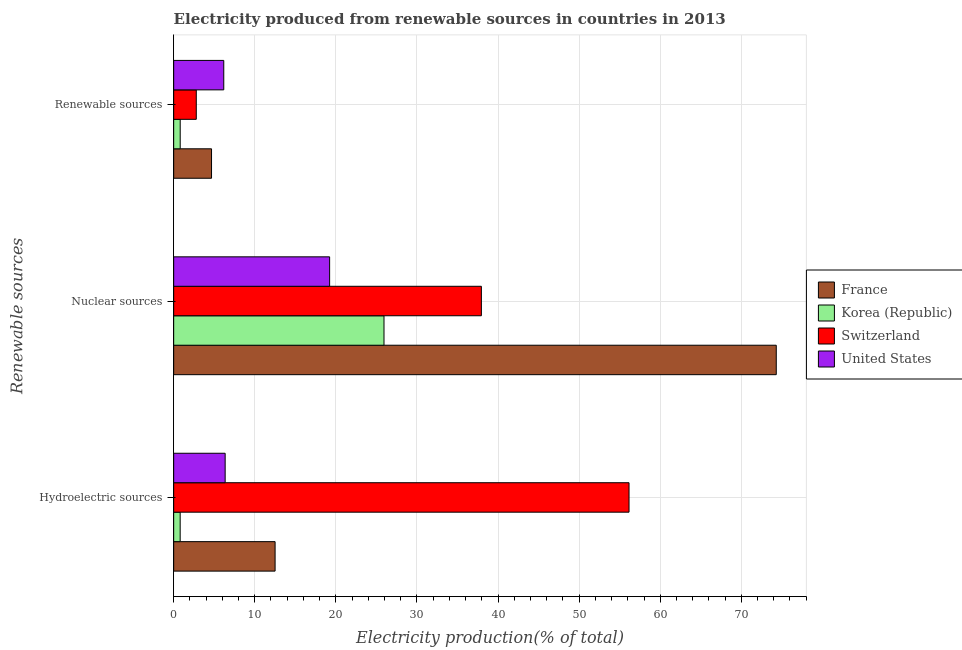How many different coloured bars are there?
Your response must be concise. 4. Are the number of bars on each tick of the Y-axis equal?
Offer a terse response. Yes. How many bars are there on the 3rd tick from the top?
Your answer should be very brief. 4. What is the label of the 2nd group of bars from the top?
Your answer should be very brief. Nuclear sources. What is the percentage of electricity produced by renewable sources in United States?
Provide a short and direct response. 6.18. Across all countries, what is the maximum percentage of electricity produced by renewable sources?
Keep it short and to the point. 6.18. Across all countries, what is the minimum percentage of electricity produced by renewable sources?
Provide a short and direct response. 0.81. What is the total percentage of electricity produced by hydroelectric sources in the graph?
Make the answer very short. 75.81. What is the difference between the percentage of electricity produced by nuclear sources in Switzerland and that in Korea (Republic)?
Your response must be concise. 12.01. What is the difference between the percentage of electricity produced by hydroelectric sources in United States and the percentage of electricity produced by renewable sources in Switzerland?
Ensure brevity in your answer.  3.56. What is the average percentage of electricity produced by renewable sources per country?
Your response must be concise. 3.61. What is the difference between the percentage of electricity produced by renewable sources and percentage of electricity produced by hydroelectric sources in United States?
Make the answer very short. -0.17. What is the ratio of the percentage of electricity produced by nuclear sources in Switzerland to that in Korea (Republic)?
Your response must be concise. 1.46. Is the difference between the percentage of electricity produced by renewable sources in France and Switzerland greater than the difference between the percentage of electricity produced by nuclear sources in France and Switzerland?
Your answer should be very brief. No. What is the difference between the highest and the second highest percentage of electricity produced by nuclear sources?
Make the answer very short. 36.36. What is the difference between the highest and the lowest percentage of electricity produced by nuclear sources?
Offer a very short reply. 55.08. What does the 1st bar from the top in Nuclear sources represents?
Offer a very short reply. United States. What does the 1st bar from the bottom in Hydroelectric sources represents?
Make the answer very short. France. Are all the bars in the graph horizontal?
Ensure brevity in your answer.  Yes. How many countries are there in the graph?
Offer a terse response. 4. What is the difference between two consecutive major ticks on the X-axis?
Your answer should be compact. 10. Are the values on the major ticks of X-axis written in scientific E-notation?
Give a very brief answer. No. How are the legend labels stacked?
Your answer should be very brief. Vertical. What is the title of the graph?
Your response must be concise. Electricity produced from renewable sources in countries in 2013. What is the label or title of the X-axis?
Ensure brevity in your answer.  Electricity production(% of total). What is the label or title of the Y-axis?
Ensure brevity in your answer.  Renewable sources. What is the Electricity production(% of total) of France in Hydroelectric sources?
Make the answer very short. 12.51. What is the Electricity production(% of total) in Korea (Republic) in Hydroelectric sources?
Ensure brevity in your answer.  0.8. What is the Electricity production(% of total) in Switzerland in Hydroelectric sources?
Provide a short and direct response. 56.15. What is the Electricity production(% of total) in United States in Hydroelectric sources?
Your response must be concise. 6.35. What is the Electricity production(% of total) of France in Nuclear sources?
Your response must be concise. 74.31. What is the Electricity production(% of total) of Korea (Republic) in Nuclear sources?
Offer a very short reply. 25.94. What is the Electricity production(% of total) in Switzerland in Nuclear sources?
Provide a short and direct response. 37.95. What is the Electricity production(% of total) in United States in Nuclear sources?
Keep it short and to the point. 19.23. What is the Electricity production(% of total) in France in Renewable sources?
Provide a succinct answer. 4.67. What is the Electricity production(% of total) in Korea (Republic) in Renewable sources?
Your answer should be compact. 0.81. What is the Electricity production(% of total) of Switzerland in Renewable sources?
Keep it short and to the point. 2.79. What is the Electricity production(% of total) in United States in Renewable sources?
Your answer should be compact. 6.18. Across all Renewable sources, what is the maximum Electricity production(% of total) of France?
Your answer should be compact. 74.31. Across all Renewable sources, what is the maximum Electricity production(% of total) of Korea (Republic)?
Provide a succinct answer. 25.94. Across all Renewable sources, what is the maximum Electricity production(% of total) in Switzerland?
Offer a terse response. 56.15. Across all Renewable sources, what is the maximum Electricity production(% of total) of United States?
Provide a succinct answer. 19.23. Across all Renewable sources, what is the minimum Electricity production(% of total) in France?
Offer a very short reply. 4.67. Across all Renewable sources, what is the minimum Electricity production(% of total) in Korea (Republic)?
Make the answer very short. 0.8. Across all Renewable sources, what is the minimum Electricity production(% of total) in Switzerland?
Give a very brief answer. 2.79. Across all Renewable sources, what is the minimum Electricity production(% of total) in United States?
Give a very brief answer. 6.18. What is the total Electricity production(% of total) of France in the graph?
Keep it short and to the point. 91.49. What is the total Electricity production(% of total) of Korea (Republic) in the graph?
Provide a short and direct response. 27.54. What is the total Electricity production(% of total) in Switzerland in the graph?
Your response must be concise. 96.89. What is the total Electricity production(% of total) in United States in the graph?
Provide a short and direct response. 31.76. What is the difference between the Electricity production(% of total) in France in Hydroelectric sources and that in Nuclear sources?
Make the answer very short. -61.8. What is the difference between the Electricity production(% of total) in Korea (Republic) in Hydroelectric sources and that in Nuclear sources?
Provide a succinct answer. -25.14. What is the difference between the Electricity production(% of total) in Switzerland in Hydroelectric sources and that in Nuclear sources?
Your response must be concise. 18.21. What is the difference between the Electricity production(% of total) in United States in Hydroelectric sources and that in Nuclear sources?
Ensure brevity in your answer.  -12.88. What is the difference between the Electricity production(% of total) of France in Hydroelectric sources and that in Renewable sources?
Ensure brevity in your answer.  7.84. What is the difference between the Electricity production(% of total) in Korea (Republic) in Hydroelectric sources and that in Renewable sources?
Provide a succinct answer. -0. What is the difference between the Electricity production(% of total) of Switzerland in Hydroelectric sources and that in Renewable sources?
Offer a terse response. 53.37. What is the difference between the Electricity production(% of total) in United States in Hydroelectric sources and that in Renewable sources?
Make the answer very short. 0.17. What is the difference between the Electricity production(% of total) of France in Nuclear sources and that in Renewable sources?
Make the answer very short. 69.64. What is the difference between the Electricity production(% of total) of Korea (Republic) in Nuclear sources and that in Renewable sources?
Make the answer very short. 25.13. What is the difference between the Electricity production(% of total) of Switzerland in Nuclear sources and that in Renewable sources?
Make the answer very short. 35.16. What is the difference between the Electricity production(% of total) in United States in Nuclear sources and that in Renewable sources?
Provide a short and direct response. 13.05. What is the difference between the Electricity production(% of total) of France in Hydroelectric sources and the Electricity production(% of total) of Korea (Republic) in Nuclear sources?
Provide a short and direct response. -13.43. What is the difference between the Electricity production(% of total) in France in Hydroelectric sources and the Electricity production(% of total) in Switzerland in Nuclear sources?
Your response must be concise. -25.44. What is the difference between the Electricity production(% of total) in France in Hydroelectric sources and the Electricity production(% of total) in United States in Nuclear sources?
Ensure brevity in your answer.  -6.72. What is the difference between the Electricity production(% of total) of Korea (Republic) in Hydroelectric sources and the Electricity production(% of total) of Switzerland in Nuclear sources?
Make the answer very short. -37.14. What is the difference between the Electricity production(% of total) of Korea (Republic) in Hydroelectric sources and the Electricity production(% of total) of United States in Nuclear sources?
Give a very brief answer. -18.43. What is the difference between the Electricity production(% of total) of Switzerland in Hydroelectric sources and the Electricity production(% of total) of United States in Nuclear sources?
Provide a succinct answer. 36.92. What is the difference between the Electricity production(% of total) in France in Hydroelectric sources and the Electricity production(% of total) in Korea (Republic) in Renewable sources?
Keep it short and to the point. 11.7. What is the difference between the Electricity production(% of total) of France in Hydroelectric sources and the Electricity production(% of total) of Switzerland in Renewable sources?
Your response must be concise. 9.72. What is the difference between the Electricity production(% of total) of France in Hydroelectric sources and the Electricity production(% of total) of United States in Renewable sources?
Provide a succinct answer. 6.33. What is the difference between the Electricity production(% of total) in Korea (Republic) in Hydroelectric sources and the Electricity production(% of total) in Switzerland in Renewable sources?
Provide a succinct answer. -1.99. What is the difference between the Electricity production(% of total) in Korea (Republic) in Hydroelectric sources and the Electricity production(% of total) in United States in Renewable sources?
Make the answer very short. -5.38. What is the difference between the Electricity production(% of total) of Switzerland in Hydroelectric sources and the Electricity production(% of total) of United States in Renewable sources?
Make the answer very short. 49.98. What is the difference between the Electricity production(% of total) in France in Nuclear sources and the Electricity production(% of total) in Korea (Republic) in Renewable sources?
Provide a succinct answer. 73.5. What is the difference between the Electricity production(% of total) in France in Nuclear sources and the Electricity production(% of total) in Switzerland in Renewable sources?
Give a very brief answer. 71.52. What is the difference between the Electricity production(% of total) of France in Nuclear sources and the Electricity production(% of total) of United States in Renewable sources?
Provide a short and direct response. 68.13. What is the difference between the Electricity production(% of total) of Korea (Republic) in Nuclear sources and the Electricity production(% of total) of Switzerland in Renewable sources?
Your answer should be very brief. 23.15. What is the difference between the Electricity production(% of total) in Korea (Republic) in Nuclear sources and the Electricity production(% of total) in United States in Renewable sources?
Make the answer very short. 19.76. What is the difference between the Electricity production(% of total) in Switzerland in Nuclear sources and the Electricity production(% of total) in United States in Renewable sources?
Offer a terse response. 31.77. What is the average Electricity production(% of total) in France per Renewable sources?
Your response must be concise. 30.5. What is the average Electricity production(% of total) of Korea (Republic) per Renewable sources?
Offer a very short reply. 9.18. What is the average Electricity production(% of total) in Switzerland per Renewable sources?
Provide a succinct answer. 32.3. What is the average Electricity production(% of total) in United States per Renewable sources?
Your response must be concise. 10.59. What is the difference between the Electricity production(% of total) of France and Electricity production(% of total) of Korea (Republic) in Hydroelectric sources?
Provide a short and direct response. 11.71. What is the difference between the Electricity production(% of total) in France and Electricity production(% of total) in Switzerland in Hydroelectric sources?
Offer a terse response. -43.65. What is the difference between the Electricity production(% of total) of France and Electricity production(% of total) of United States in Hydroelectric sources?
Ensure brevity in your answer.  6.16. What is the difference between the Electricity production(% of total) in Korea (Republic) and Electricity production(% of total) in Switzerland in Hydroelectric sources?
Provide a short and direct response. -55.35. What is the difference between the Electricity production(% of total) of Korea (Republic) and Electricity production(% of total) of United States in Hydroelectric sources?
Offer a terse response. -5.55. What is the difference between the Electricity production(% of total) in Switzerland and Electricity production(% of total) in United States in Hydroelectric sources?
Keep it short and to the point. 49.8. What is the difference between the Electricity production(% of total) of France and Electricity production(% of total) of Korea (Republic) in Nuclear sources?
Your answer should be very brief. 48.37. What is the difference between the Electricity production(% of total) of France and Electricity production(% of total) of Switzerland in Nuclear sources?
Provide a short and direct response. 36.36. What is the difference between the Electricity production(% of total) of France and Electricity production(% of total) of United States in Nuclear sources?
Your answer should be compact. 55.08. What is the difference between the Electricity production(% of total) of Korea (Republic) and Electricity production(% of total) of Switzerland in Nuclear sources?
Make the answer very short. -12.01. What is the difference between the Electricity production(% of total) of Korea (Republic) and Electricity production(% of total) of United States in Nuclear sources?
Your response must be concise. 6.71. What is the difference between the Electricity production(% of total) in Switzerland and Electricity production(% of total) in United States in Nuclear sources?
Provide a succinct answer. 18.71. What is the difference between the Electricity production(% of total) of France and Electricity production(% of total) of Korea (Republic) in Renewable sources?
Provide a succinct answer. 3.86. What is the difference between the Electricity production(% of total) in France and Electricity production(% of total) in Switzerland in Renewable sources?
Provide a short and direct response. 1.88. What is the difference between the Electricity production(% of total) in France and Electricity production(% of total) in United States in Renewable sources?
Offer a terse response. -1.51. What is the difference between the Electricity production(% of total) of Korea (Republic) and Electricity production(% of total) of Switzerland in Renewable sources?
Your answer should be compact. -1.98. What is the difference between the Electricity production(% of total) in Korea (Republic) and Electricity production(% of total) in United States in Renewable sources?
Provide a short and direct response. -5.37. What is the difference between the Electricity production(% of total) in Switzerland and Electricity production(% of total) in United States in Renewable sources?
Make the answer very short. -3.39. What is the ratio of the Electricity production(% of total) in France in Hydroelectric sources to that in Nuclear sources?
Make the answer very short. 0.17. What is the ratio of the Electricity production(% of total) of Korea (Republic) in Hydroelectric sources to that in Nuclear sources?
Keep it short and to the point. 0.03. What is the ratio of the Electricity production(% of total) of Switzerland in Hydroelectric sources to that in Nuclear sources?
Provide a succinct answer. 1.48. What is the ratio of the Electricity production(% of total) of United States in Hydroelectric sources to that in Nuclear sources?
Offer a very short reply. 0.33. What is the ratio of the Electricity production(% of total) of France in Hydroelectric sources to that in Renewable sources?
Your answer should be very brief. 2.68. What is the ratio of the Electricity production(% of total) in Switzerland in Hydroelectric sources to that in Renewable sources?
Give a very brief answer. 20.15. What is the ratio of the Electricity production(% of total) in United States in Hydroelectric sources to that in Renewable sources?
Your answer should be very brief. 1.03. What is the ratio of the Electricity production(% of total) in France in Nuclear sources to that in Renewable sources?
Offer a very short reply. 15.91. What is the ratio of the Electricity production(% of total) of Korea (Republic) in Nuclear sources to that in Renewable sources?
Provide a succinct answer. 32.19. What is the ratio of the Electricity production(% of total) of Switzerland in Nuclear sources to that in Renewable sources?
Your response must be concise. 13.61. What is the ratio of the Electricity production(% of total) in United States in Nuclear sources to that in Renewable sources?
Provide a short and direct response. 3.11. What is the difference between the highest and the second highest Electricity production(% of total) of France?
Your answer should be compact. 61.8. What is the difference between the highest and the second highest Electricity production(% of total) of Korea (Republic)?
Provide a succinct answer. 25.13. What is the difference between the highest and the second highest Electricity production(% of total) in Switzerland?
Keep it short and to the point. 18.21. What is the difference between the highest and the second highest Electricity production(% of total) of United States?
Make the answer very short. 12.88. What is the difference between the highest and the lowest Electricity production(% of total) in France?
Your answer should be compact. 69.64. What is the difference between the highest and the lowest Electricity production(% of total) in Korea (Republic)?
Offer a very short reply. 25.14. What is the difference between the highest and the lowest Electricity production(% of total) in Switzerland?
Give a very brief answer. 53.37. What is the difference between the highest and the lowest Electricity production(% of total) in United States?
Offer a terse response. 13.05. 